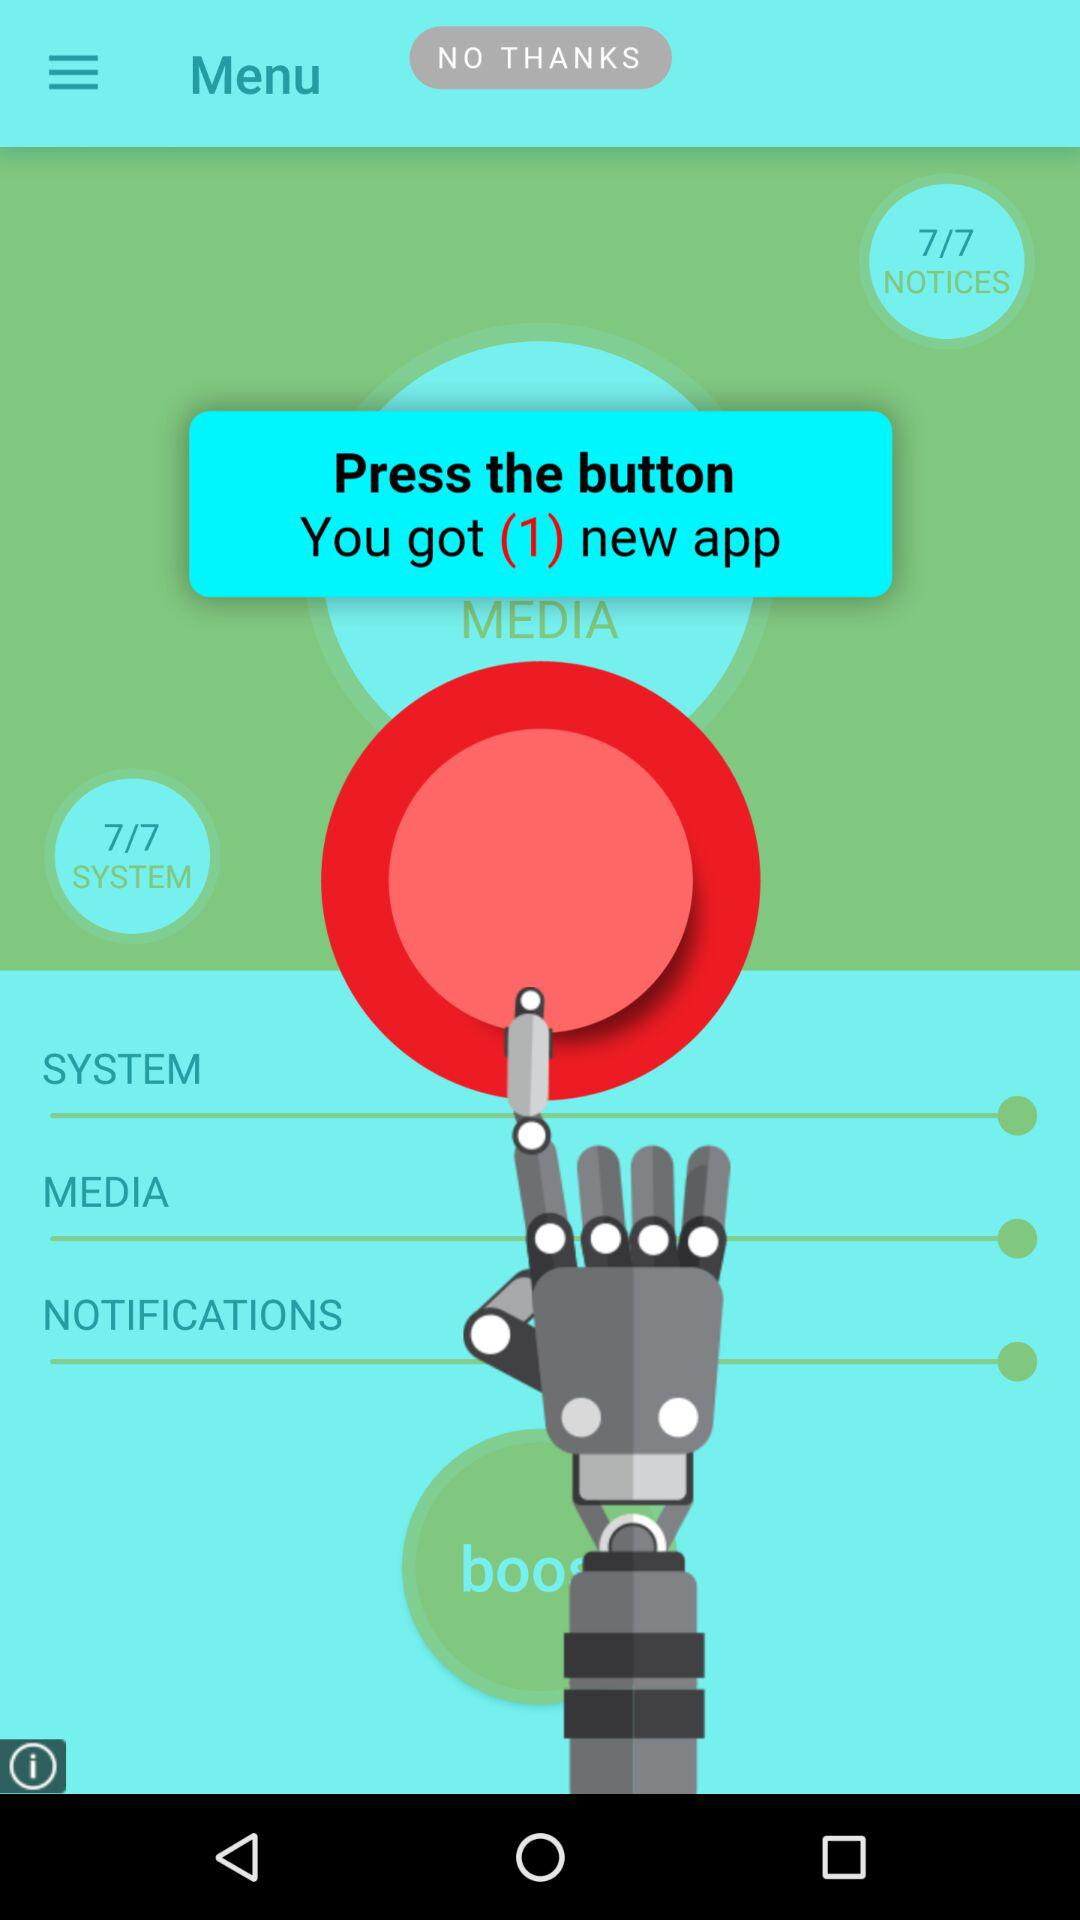How many notices are there? There are 7 notices. 